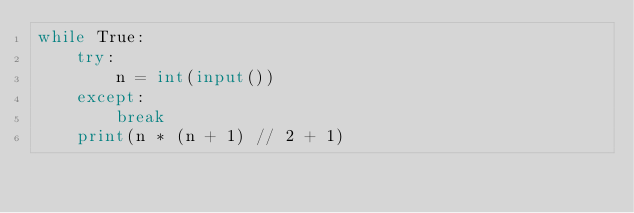<code> <loc_0><loc_0><loc_500><loc_500><_Python_>while True:
    try:
        n = int(input())
    except:
        break
    print(n * (n + 1) // 2 + 1)</code> 